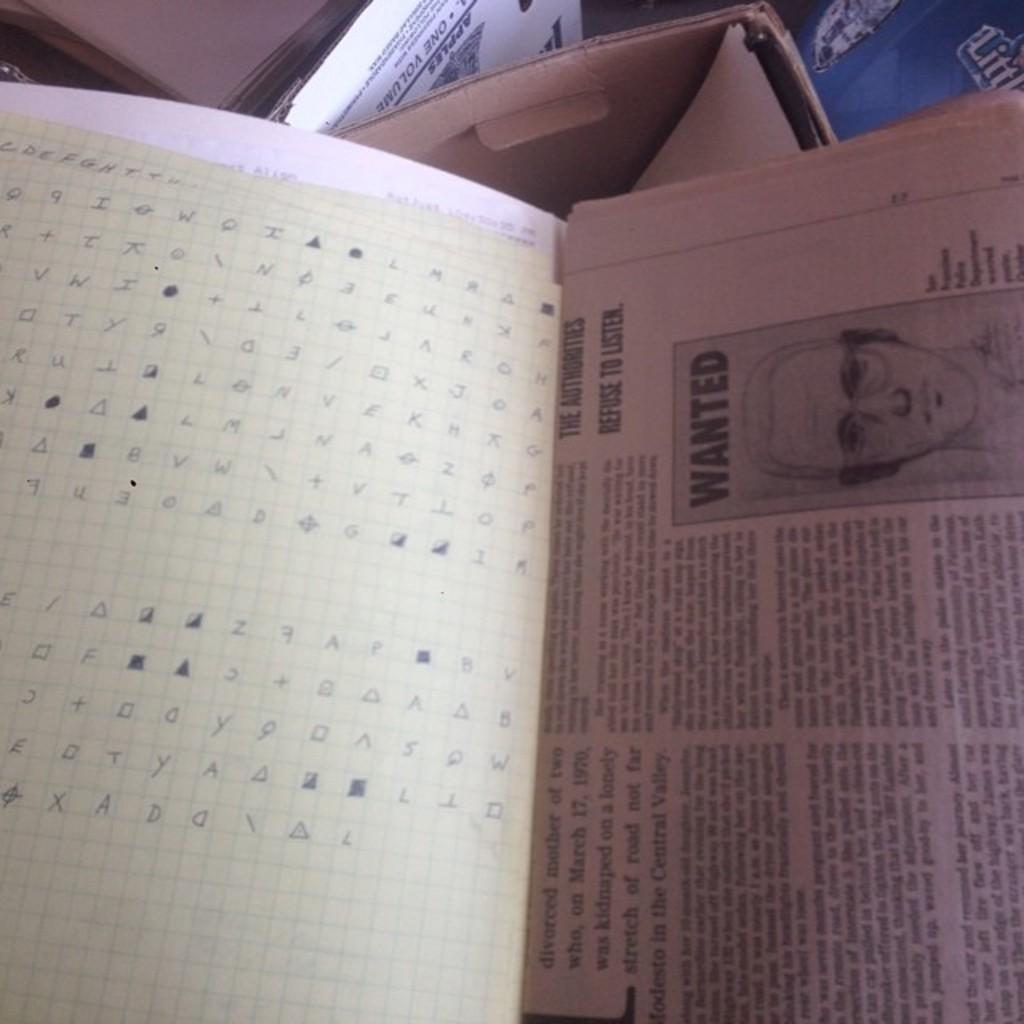<image>
Summarize the visual content of the image. An open book with an image of a wanted poster on it. 